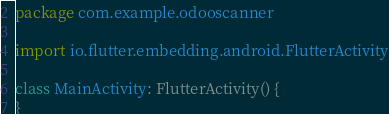Convert code to text. <code><loc_0><loc_0><loc_500><loc_500><_Kotlin_>package com.example.odooscanner

import io.flutter.embedding.android.FlutterActivity

class MainActivity: FlutterActivity() {
}
</code> 